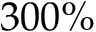<formula> <loc_0><loc_0><loc_500><loc_500>3 0 0 \%</formula> 